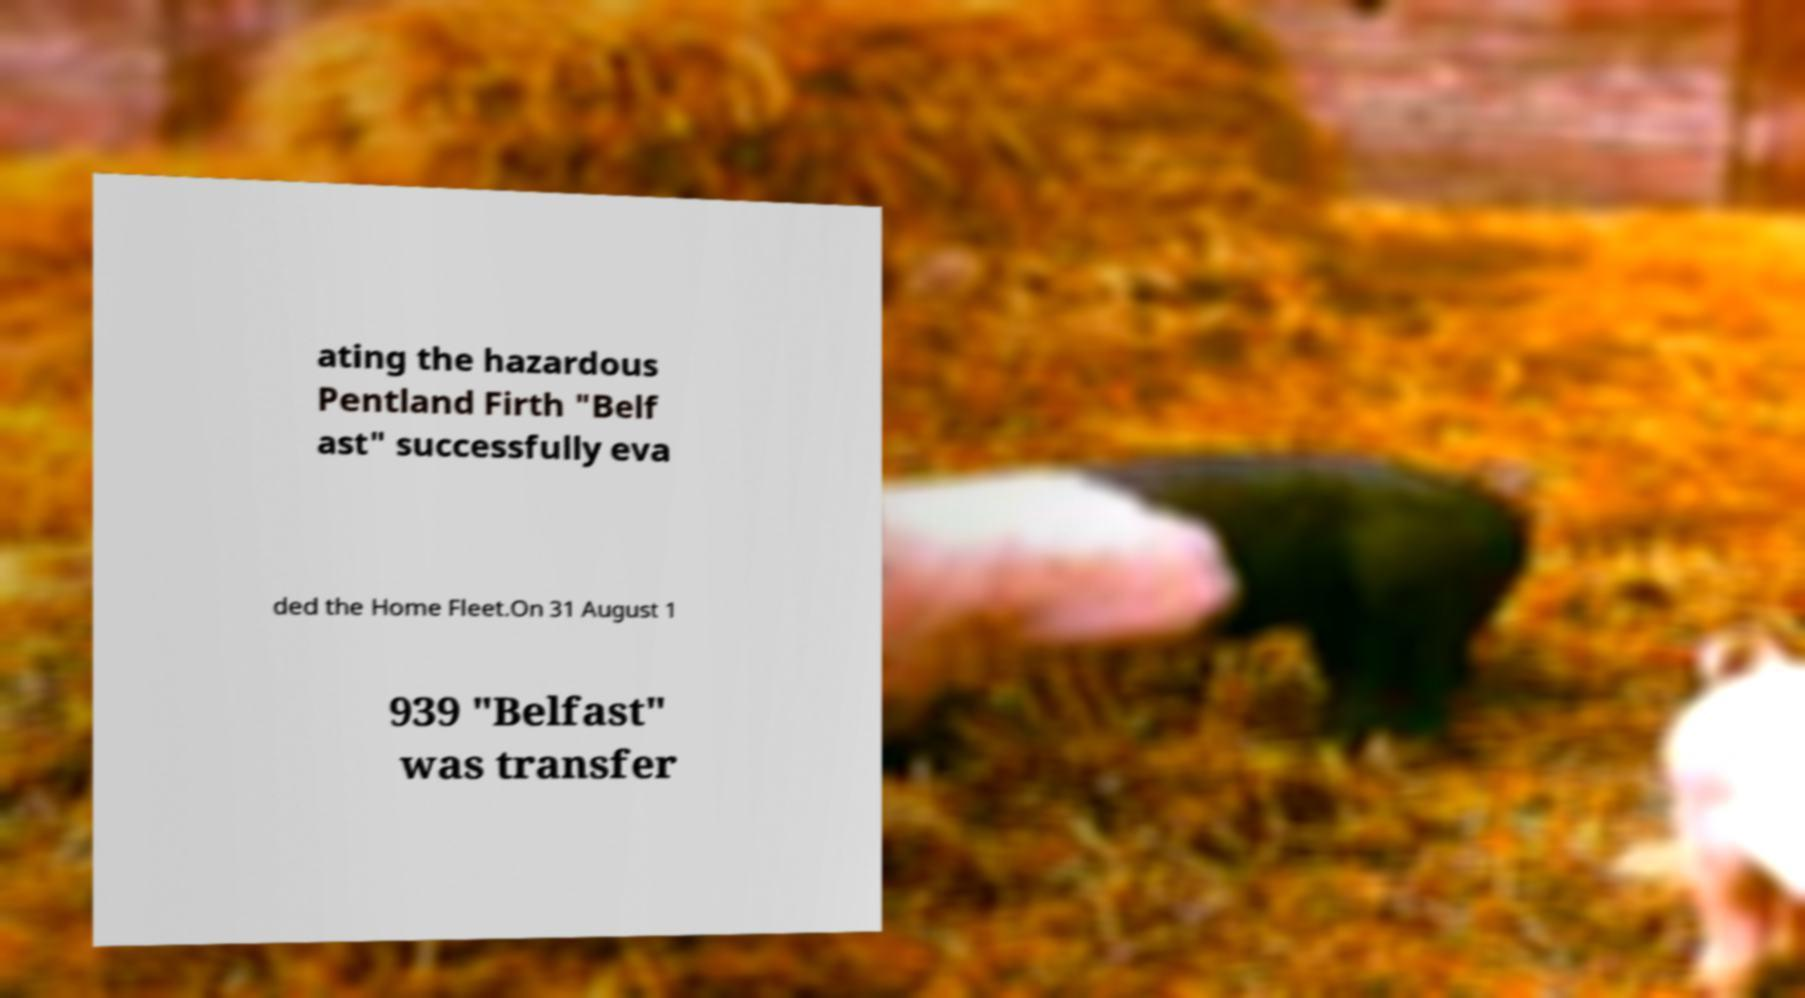I need the written content from this picture converted into text. Can you do that? ating the hazardous Pentland Firth "Belf ast" successfully eva ded the Home Fleet.On 31 August 1 939 "Belfast" was transfer 